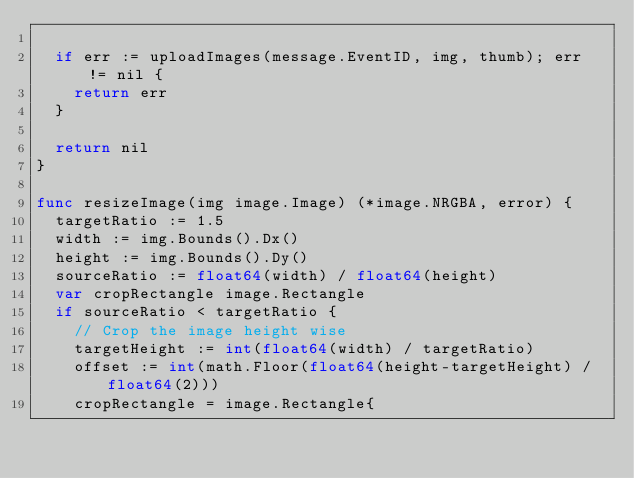<code> <loc_0><loc_0><loc_500><loc_500><_Go_>
	if err := uploadImages(message.EventID, img, thumb); err != nil {
		return err
	}

	return nil
}

func resizeImage(img image.Image) (*image.NRGBA, error) {
	targetRatio := 1.5
	width := img.Bounds().Dx()
	height := img.Bounds().Dy()
	sourceRatio := float64(width) / float64(height)
	var cropRectangle image.Rectangle
	if sourceRatio < targetRatio {
		// Crop the image height wise
		targetHeight := int(float64(width) / targetRatio)
		offset := int(math.Floor(float64(height-targetHeight) / float64(2)))
		cropRectangle = image.Rectangle{</code> 